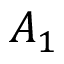<formula> <loc_0><loc_0><loc_500><loc_500>A _ { 1 }</formula> 